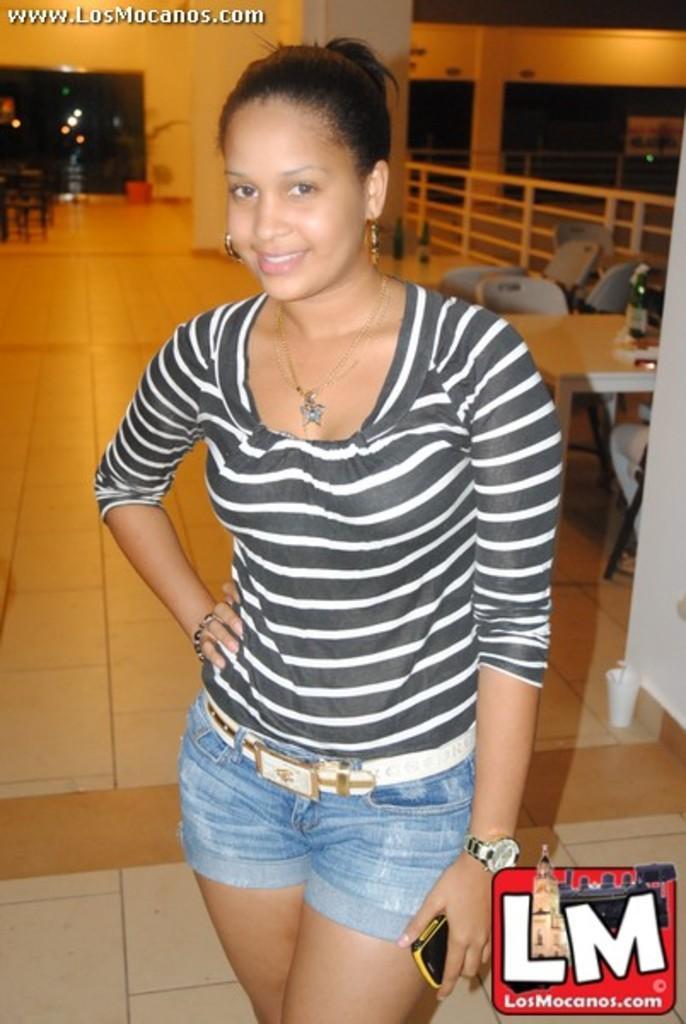How would you summarize this image in a sentence or two? Front this woman is smiling and holding a mobile. Background there is a tile floor, tables, chairs, fence, bottles and plant. Left side corner of the image there is a watermark. Right side bottom of the image there is a logo. 